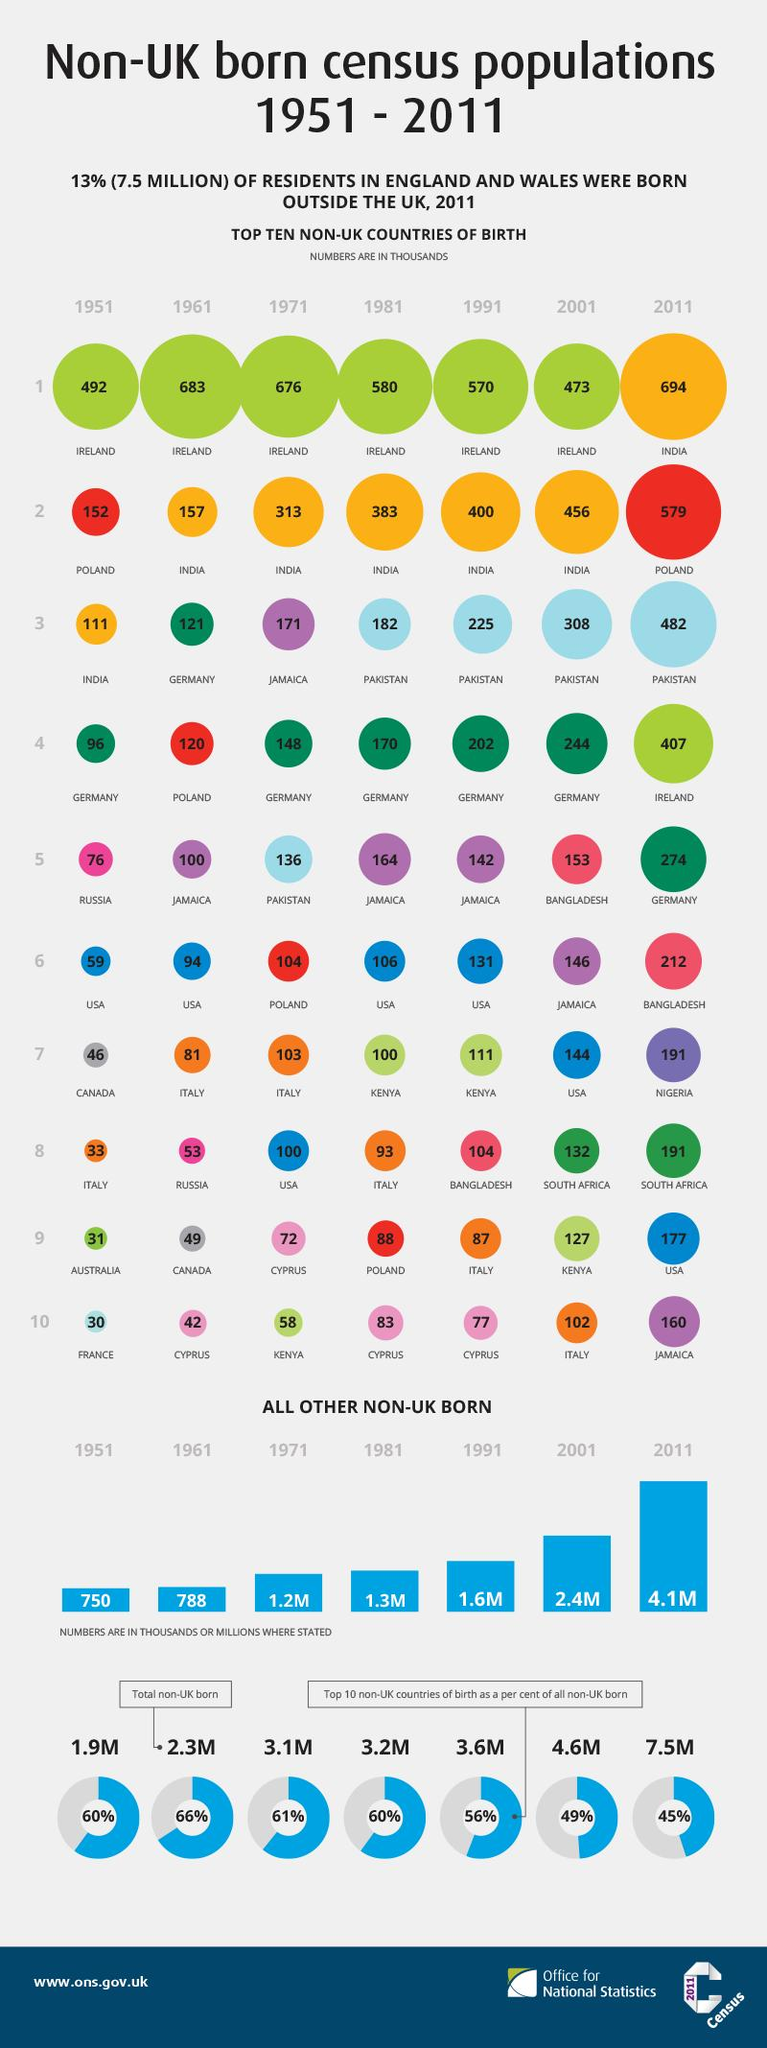Mention a couple of crucial points in this snapshot. In 2011, there were approximately 407,000 non-UK born residents who were from Ireland. According to data from 2011, the total population of non-UK born residents was approximately 7.5 million. In 1981, the total population of non-UK born residents was approximately 3.2 million. In 1951, the total population of non-UK born residents was 1.9 million. In 1961, there were approximately 121 thousand non-UK born residents who were from Germany. 